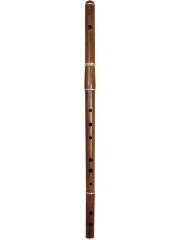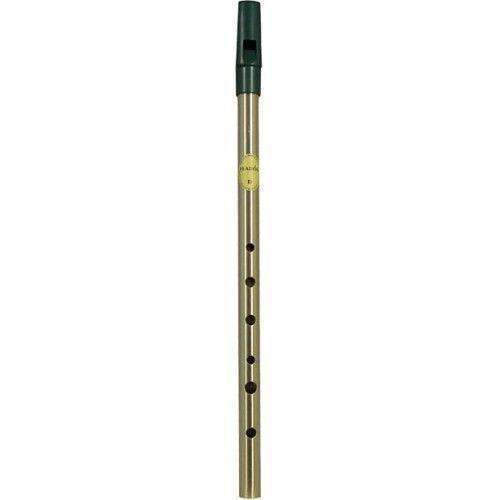The first image is the image on the left, the second image is the image on the right. Evaluate the accuracy of this statement regarding the images: "There is exactly one flute.". Is it true? Answer yes or no. No. The first image is the image on the left, the second image is the image on the right. Given the left and right images, does the statement "There is a solid metal thing with no visible holes in the right image." hold true? Answer yes or no. No. 